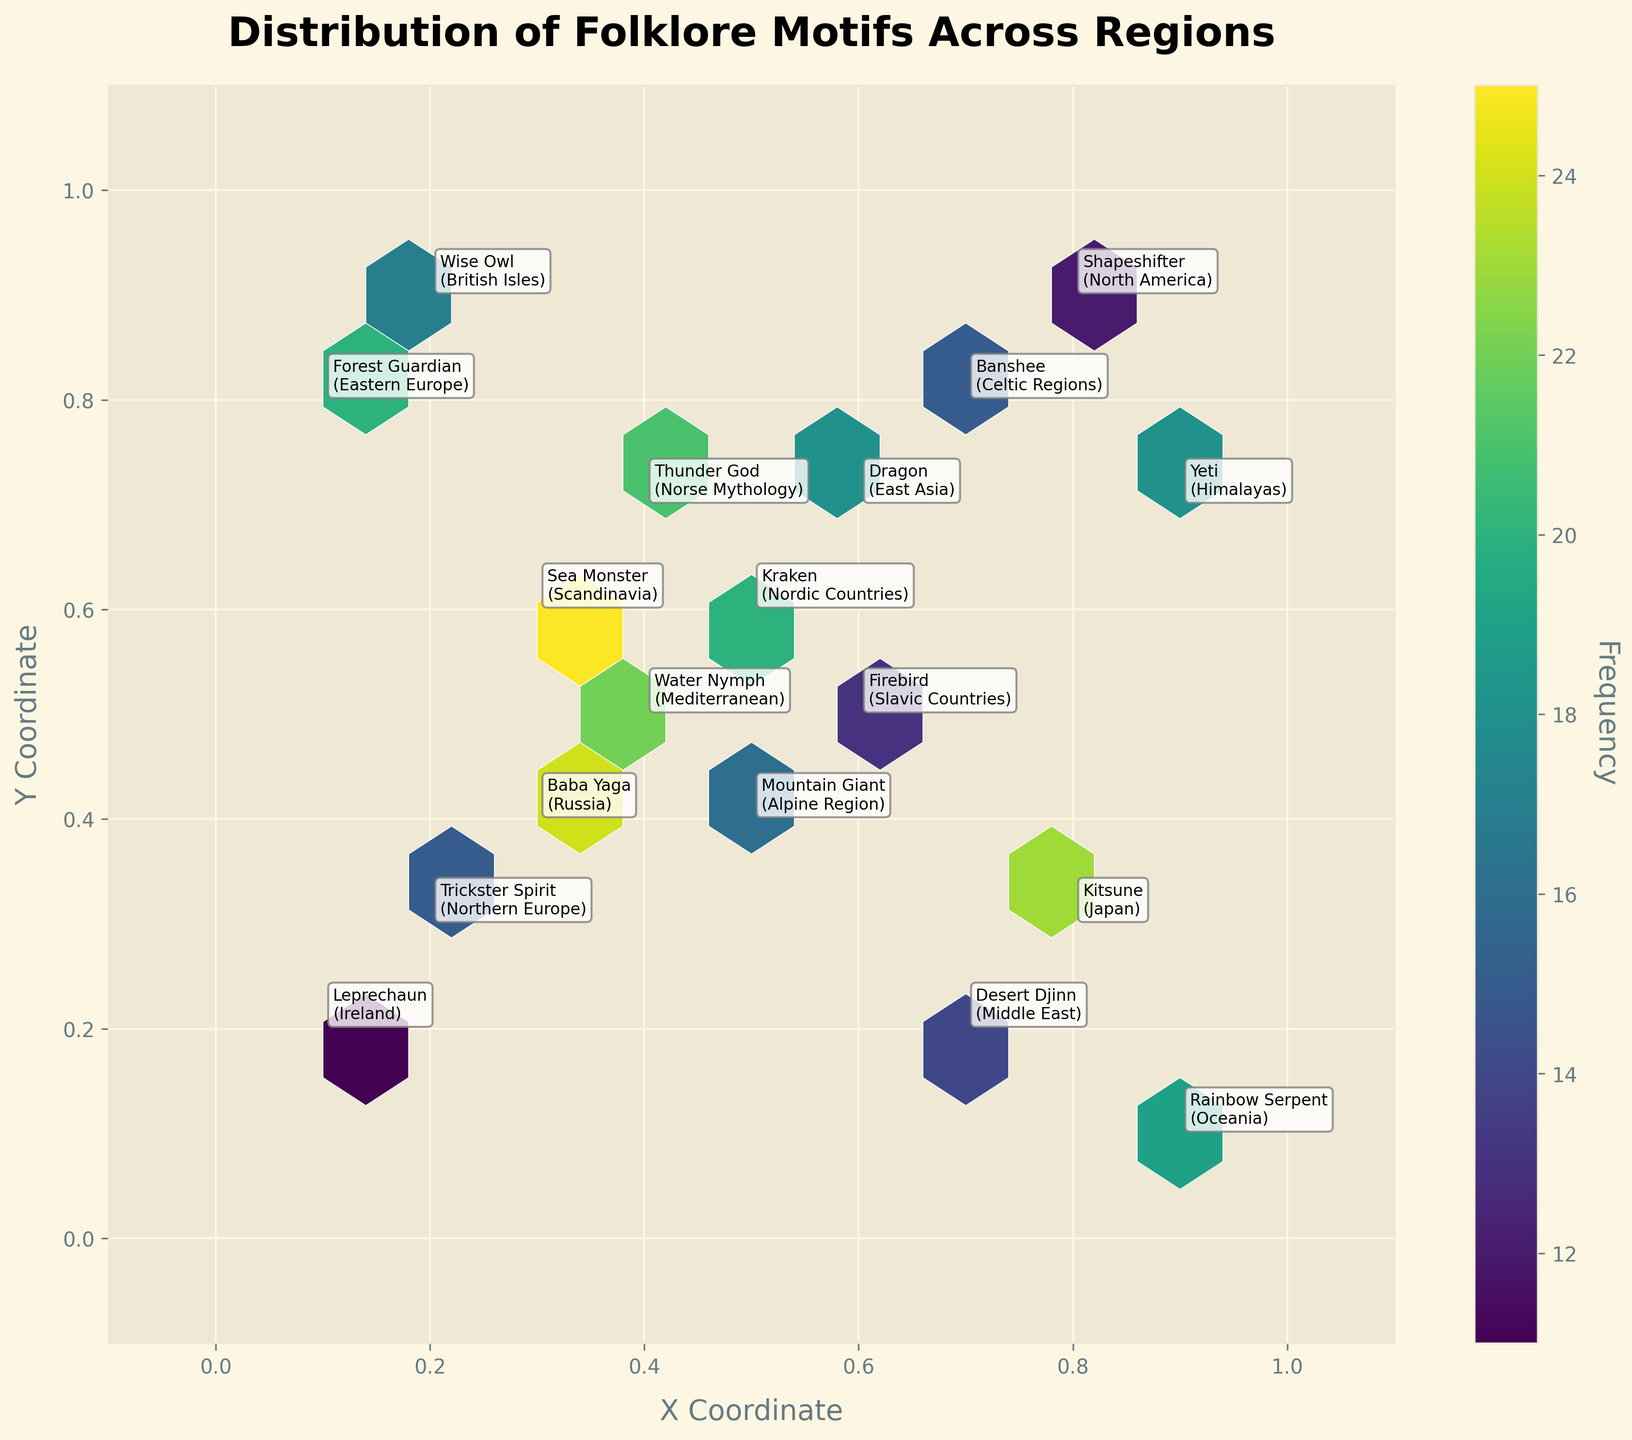what's the title of the plot? The title is usually mentioned at the top center of the plot. In this case, it is "Distribution of Folklore Motifs Across Regions".
Answer: Distribution of Folklore Motifs Across Regions how many folklore motifs are annotated on the plot? Each motif is annotated with text on the plot and there are a total of 18 unique annotations present.
Answer: 18 what region is associated with the motif “Trickster Spirit”? The region is usually noted in parentheses after the motif. For "Trickster Spirit", it is "Northern Europe".
Answer: Northern Europe which folklore motif has the highest frequency? Observing the color intensity in the hexbin plot will indicate the highest frequency. The motif "Sea Monster" has a frequency of 25, which is the highest.
Answer: Sea Monster are there more motifs clustered around the center or the edges of the plot? By examining the density of the hexagons, it looks like there are more motifs clustered around the central area of the plot rather than the edges.
Answer: Center which region has the lowest frequency motif and what is it? By comparing the frequencies, "Leprechaun" in Ireland has the lowest frequency, which is 11.
Answer: Leprechaun, Ireland compare the frequencies of “Dragon” and “Baba Yaga”. Which one is higher? Checking the annotated frequencies, "Dragon" has a frequency of 18 while "Baba Yaga" has a frequency of 24. "Baba Yaga" is higher.
Answer: Baba Yaga what is the average frequency of all motifs included in this plot? Adding the frequencies and dividing by the count of values: (15+22+18+12+20+25+16+14+19+17+21+13+23+11+24+20+15+18)/18; The sum is 323, averaging to approximately 17.94.
Answer: 17.94 is the “Wise Owl” more frequent than the “Yeti”? The frequency of "Wise Owl" is 17 and "Yeti" is 18. "Yeti" has a higher frequency.
Answer: No which motif and region pair is closest to the y-axis at x=0.1? Observing the plot, the motif "Leprechaun" in Ireland is closest to the y-axis at x=0.1.
Answer: Leprechaun, Ireland 